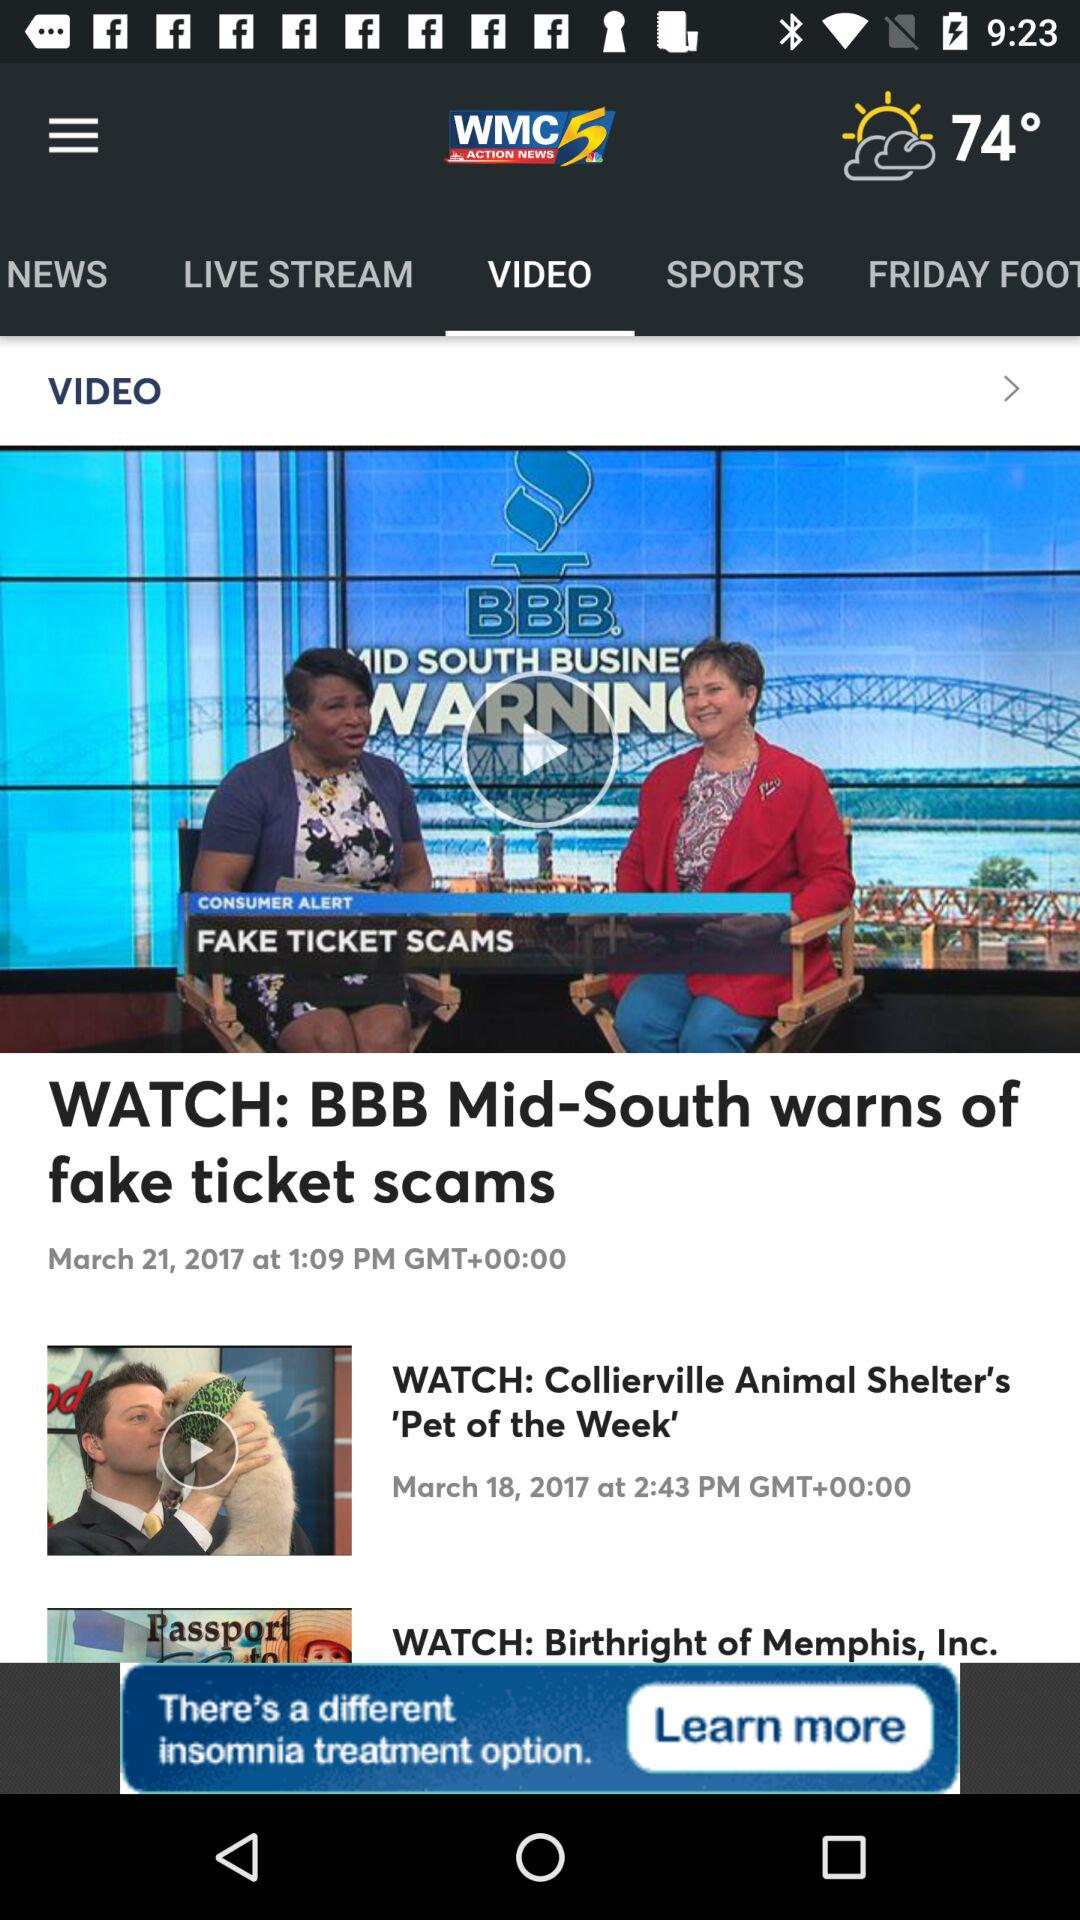When does the Collierville Animal Shelter's "Pet of the Week" show air? The show aired on March 18, 2017 at 2:43 PM. 